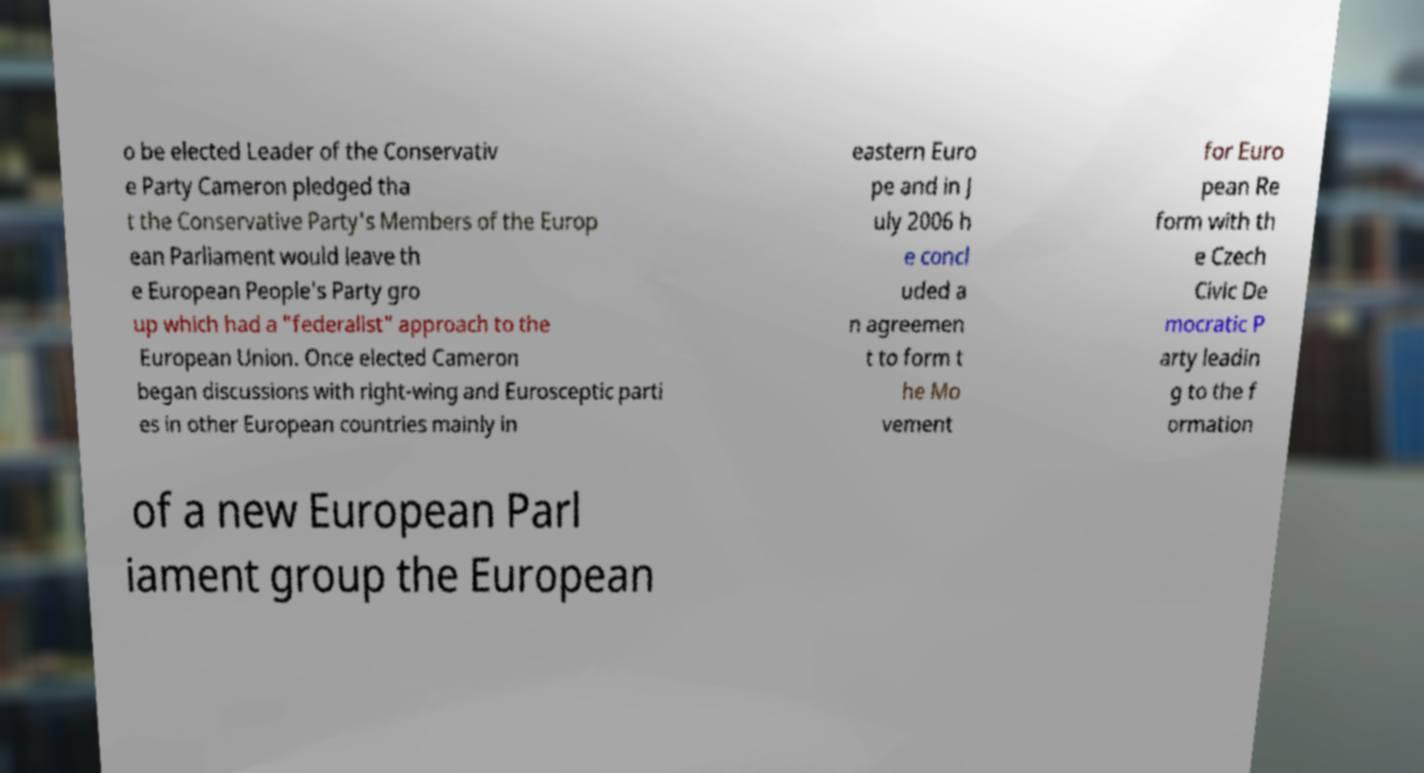What messages or text are displayed in this image? I need them in a readable, typed format. o be elected Leader of the Conservativ e Party Cameron pledged tha t the Conservative Party's Members of the Europ ean Parliament would leave th e European People's Party gro up which had a "federalist" approach to the European Union. Once elected Cameron began discussions with right-wing and Eurosceptic parti es in other European countries mainly in eastern Euro pe and in J uly 2006 h e concl uded a n agreemen t to form t he Mo vement for Euro pean Re form with th e Czech Civic De mocratic P arty leadin g to the f ormation of a new European Parl iament group the European 